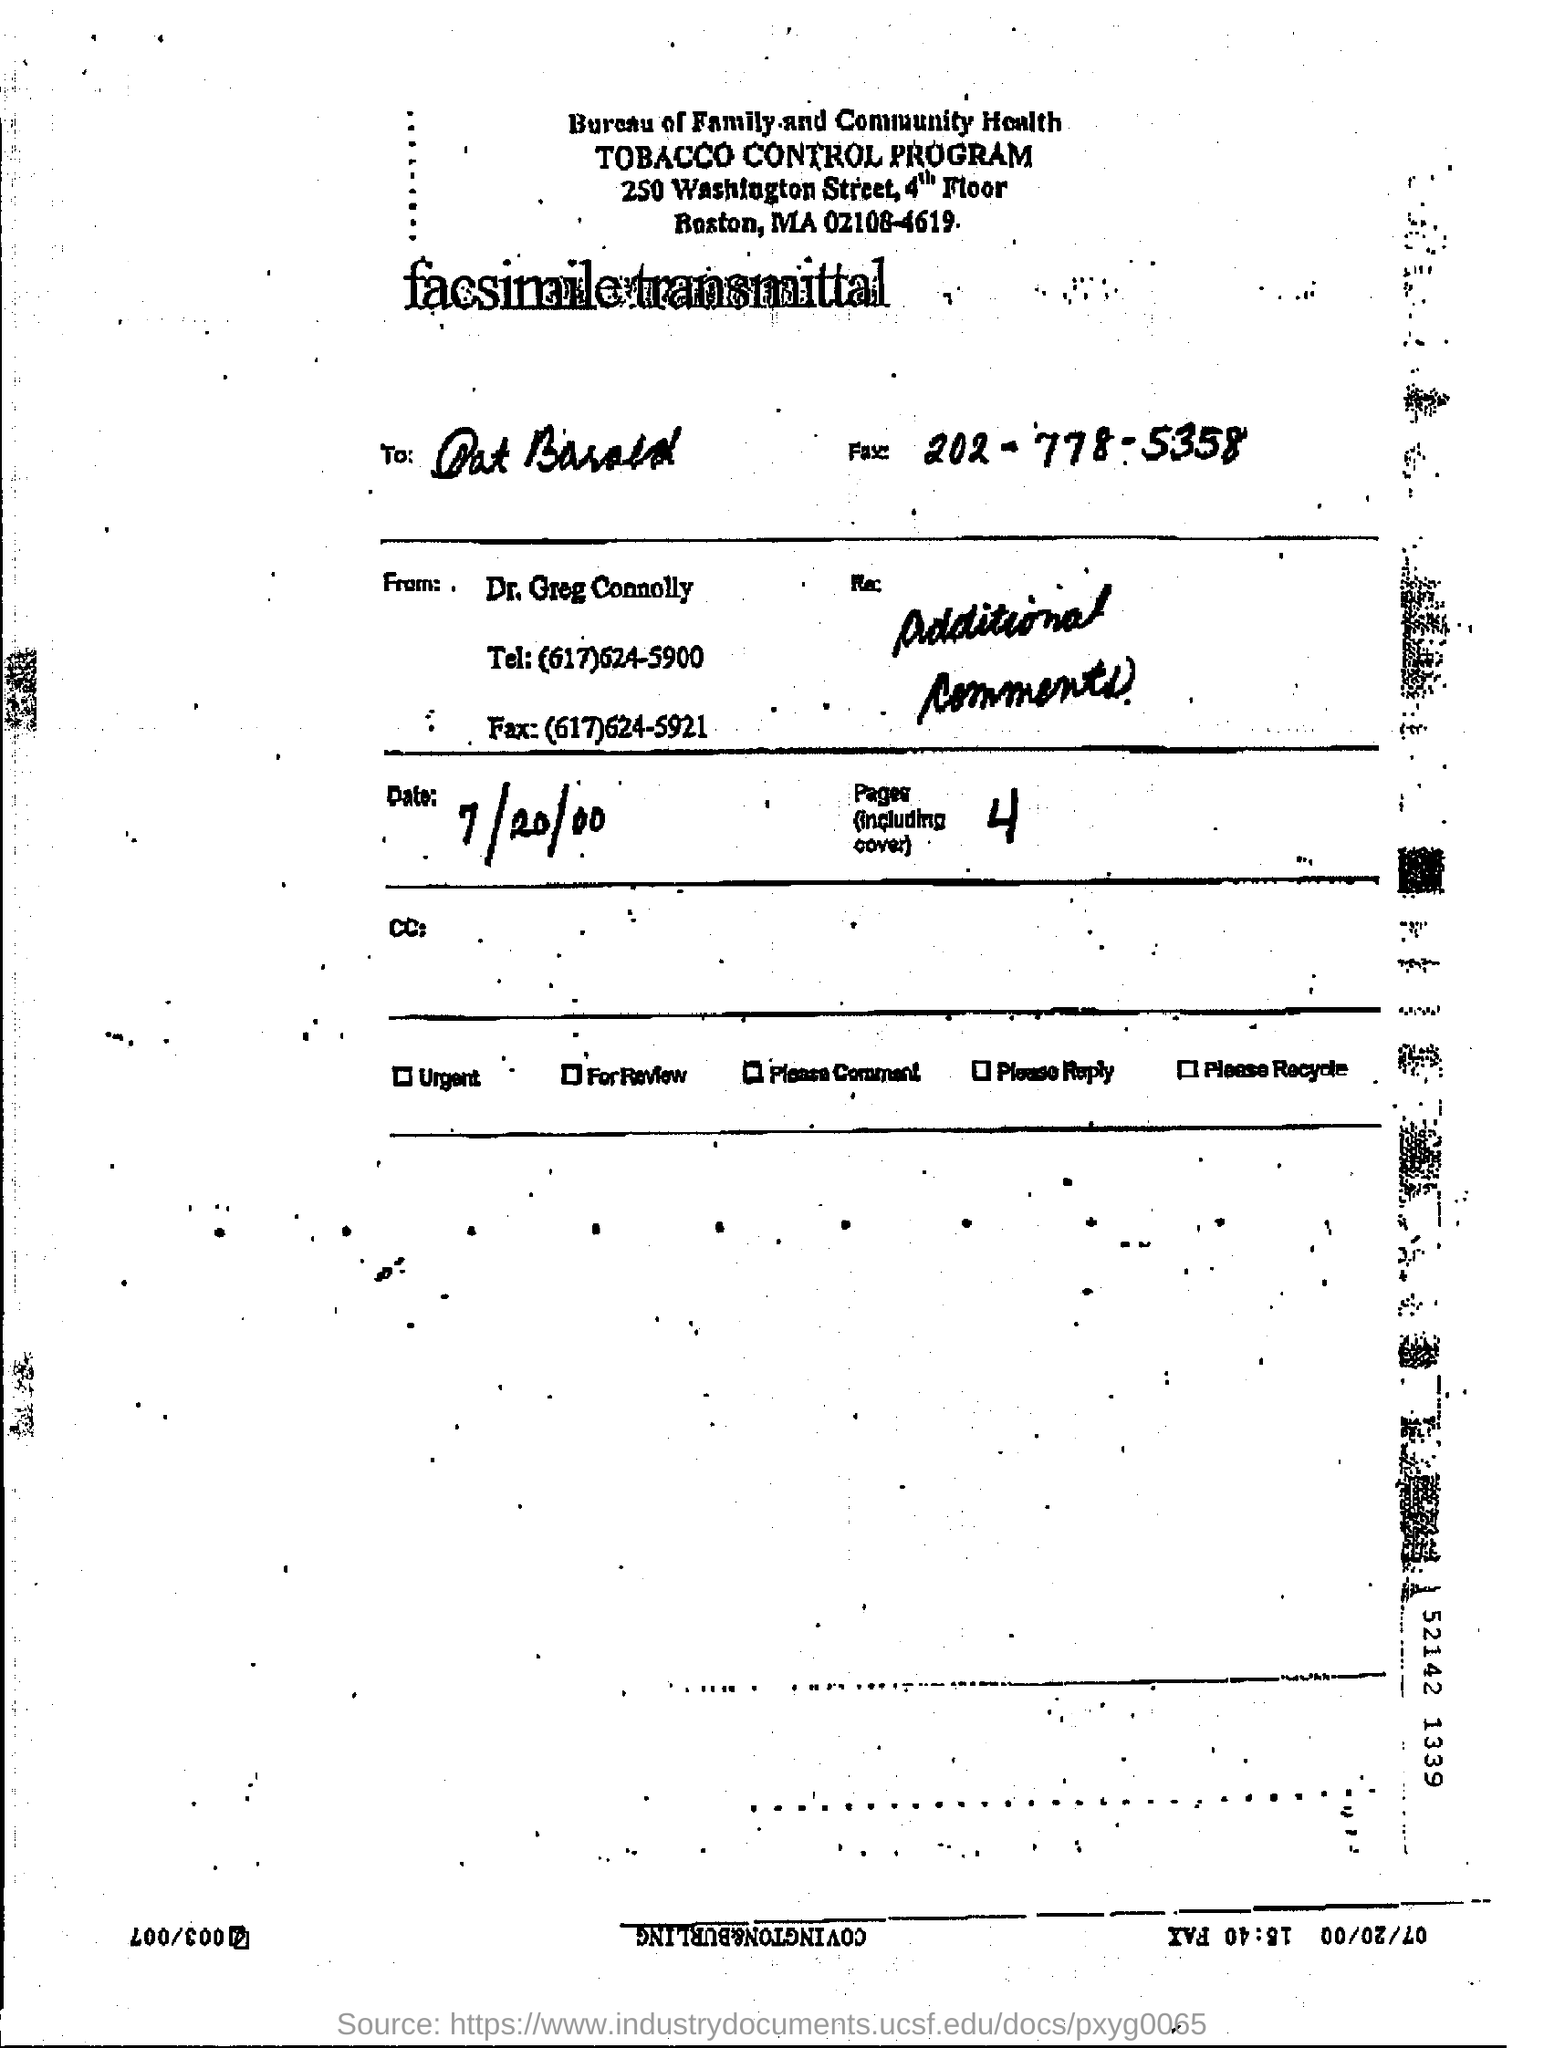how many pages are there (including cover) ? The document contains a total of 4 pages, including the cover. 